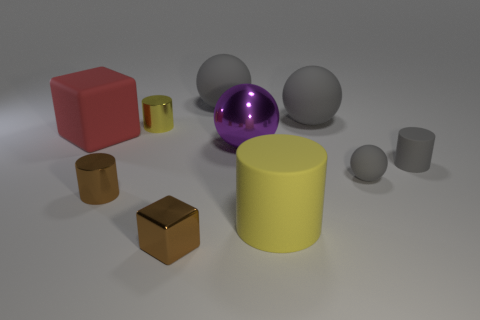Subtract all gray cylinders. How many gray spheres are left? 3 Subtract 1 cylinders. How many cylinders are left? 3 Subtract all cylinders. How many objects are left? 6 Subtract all small cubes. Subtract all big yellow matte things. How many objects are left? 8 Add 4 big purple balls. How many big purple balls are left? 5 Add 1 brown metallic things. How many brown metallic things exist? 3 Subtract 0 brown balls. How many objects are left? 10 